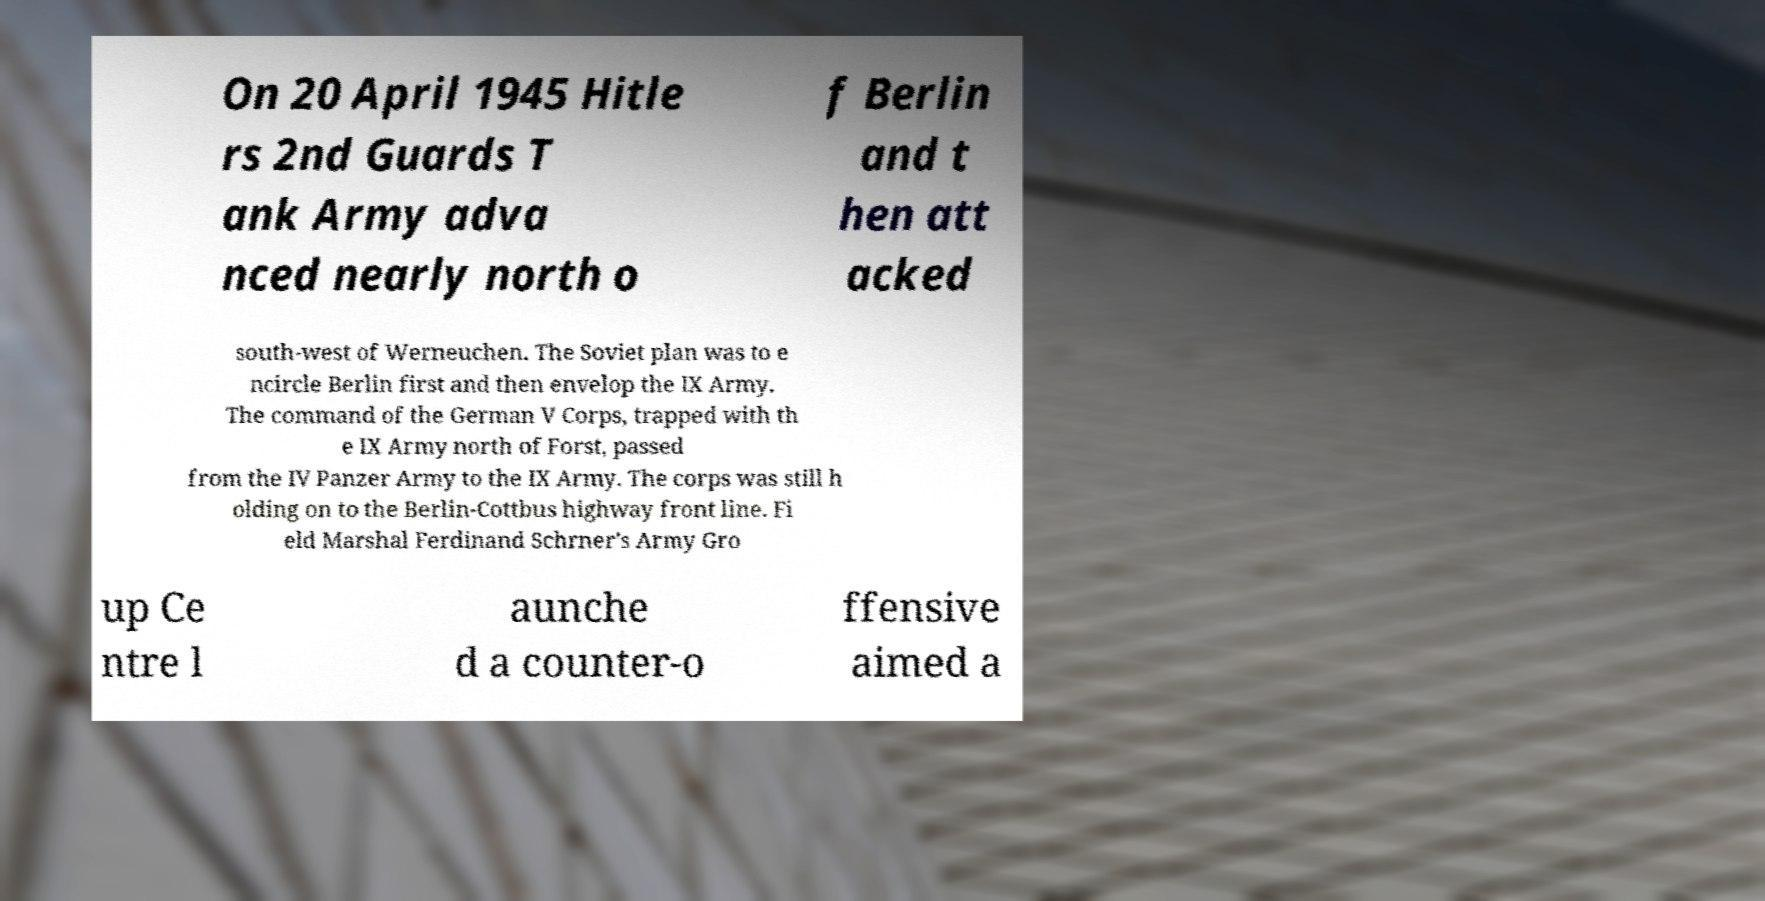Please read and relay the text visible in this image. What does it say? On 20 April 1945 Hitle rs 2nd Guards T ank Army adva nced nearly north o f Berlin and t hen att acked south-west of Werneuchen. The Soviet plan was to e ncircle Berlin first and then envelop the IX Army. The command of the German V Corps, trapped with th e IX Army north of Forst, passed from the IV Panzer Army to the IX Army. The corps was still h olding on to the Berlin-Cottbus highway front line. Fi eld Marshal Ferdinand Schrner's Army Gro up Ce ntre l aunche d a counter-o ffensive aimed a 